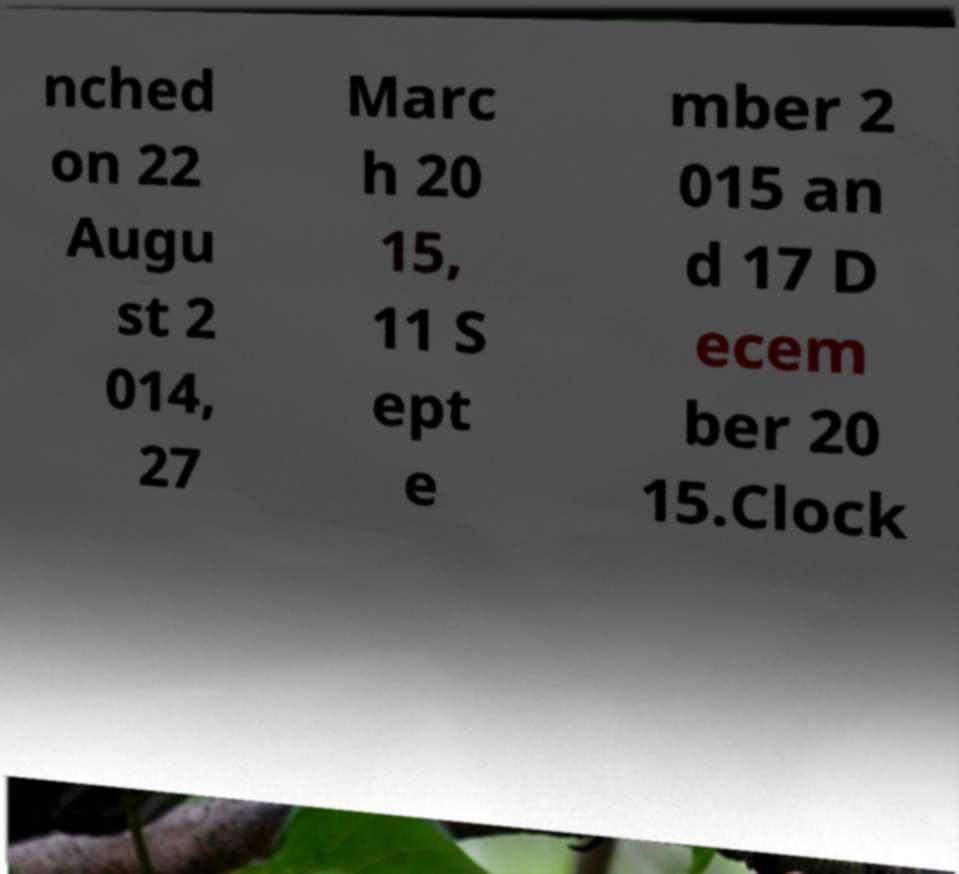Could you assist in decoding the text presented in this image and type it out clearly? nched on 22 Augu st 2 014, 27 Marc h 20 15, 11 S ept e mber 2 015 an d 17 D ecem ber 20 15.Clock 